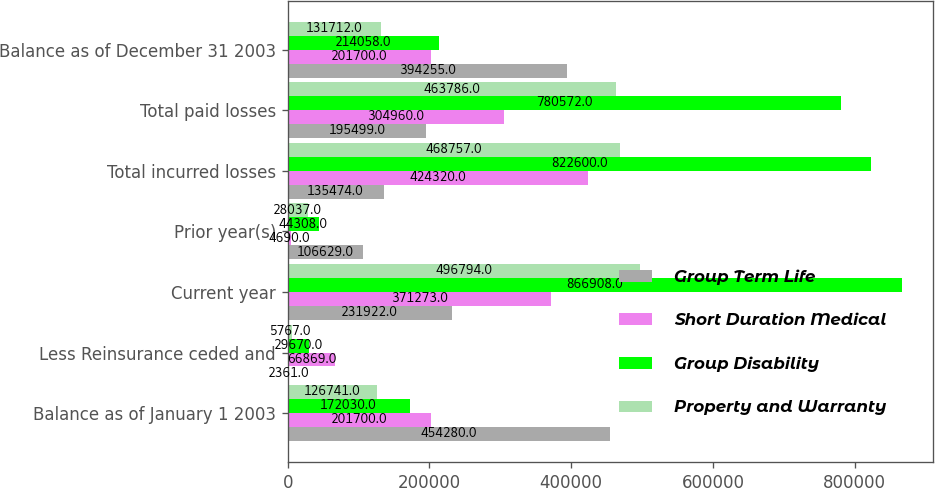Convert chart. <chart><loc_0><loc_0><loc_500><loc_500><stacked_bar_chart><ecel><fcel>Balance as of January 1 2003<fcel>Less Reinsurance ceded and<fcel>Current year<fcel>Prior year(s)<fcel>Total incurred losses<fcel>Total paid losses<fcel>Balance as of December 31 2003<nl><fcel>Group Term Life<fcel>454280<fcel>2361<fcel>231922<fcel>106629<fcel>135474<fcel>195499<fcel>394255<nl><fcel>Short Duration Medical<fcel>201700<fcel>66869<fcel>371273<fcel>4690<fcel>424320<fcel>304960<fcel>201700<nl><fcel>Group Disability<fcel>172030<fcel>29670<fcel>866908<fcel>44308<fcel>822600<fcel>780572<fcel>214058<nl><fcel>Property and Warranty<fcel>126741<fcel>5767<fcel>496794<fcel>28037<fcel>468757<fcel>463786<fcel>131712<nl></chart> 